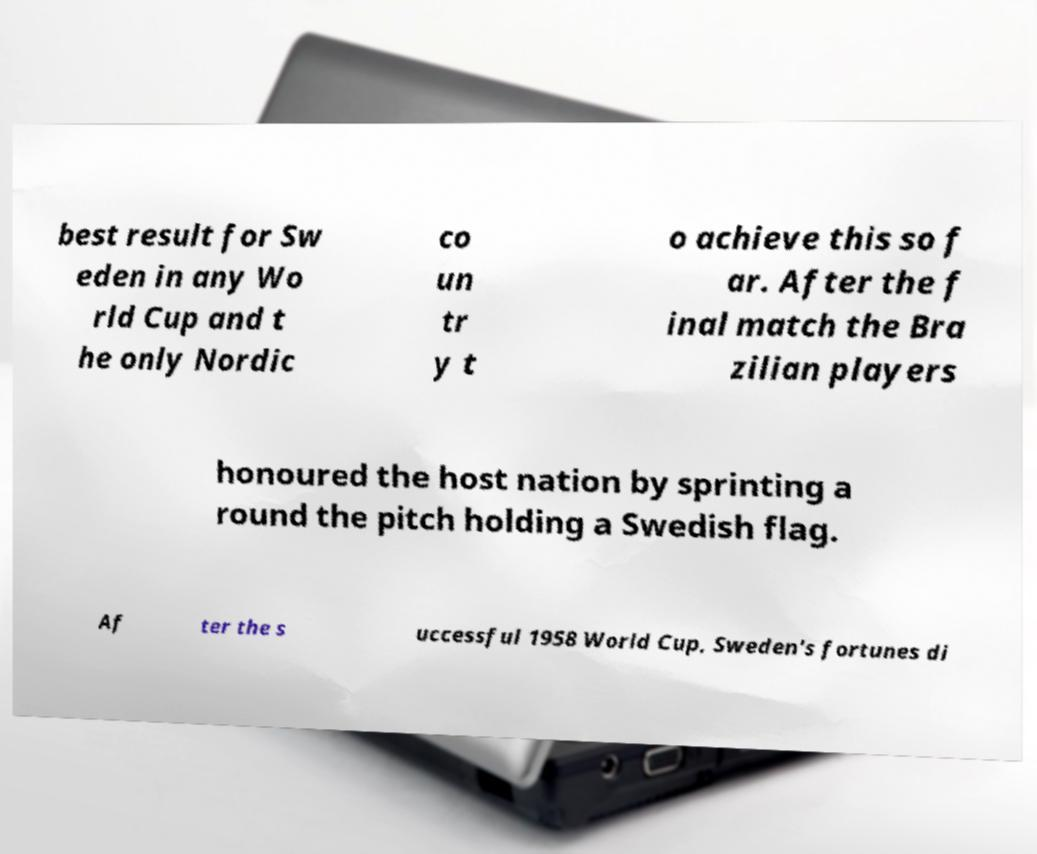Can you accurately transcribe the text from the provided image for me? best result for Sw eden in any Wo rld Cup and t he only Nordic co un tr y t o achieve this so f ar. After the f inal match the Bra zilian players honoured the host nation by sprinting a round the pitch holding a Swedish flag. Af ter the s uccessful 1958 World Cup, Sweden's fortunes di 